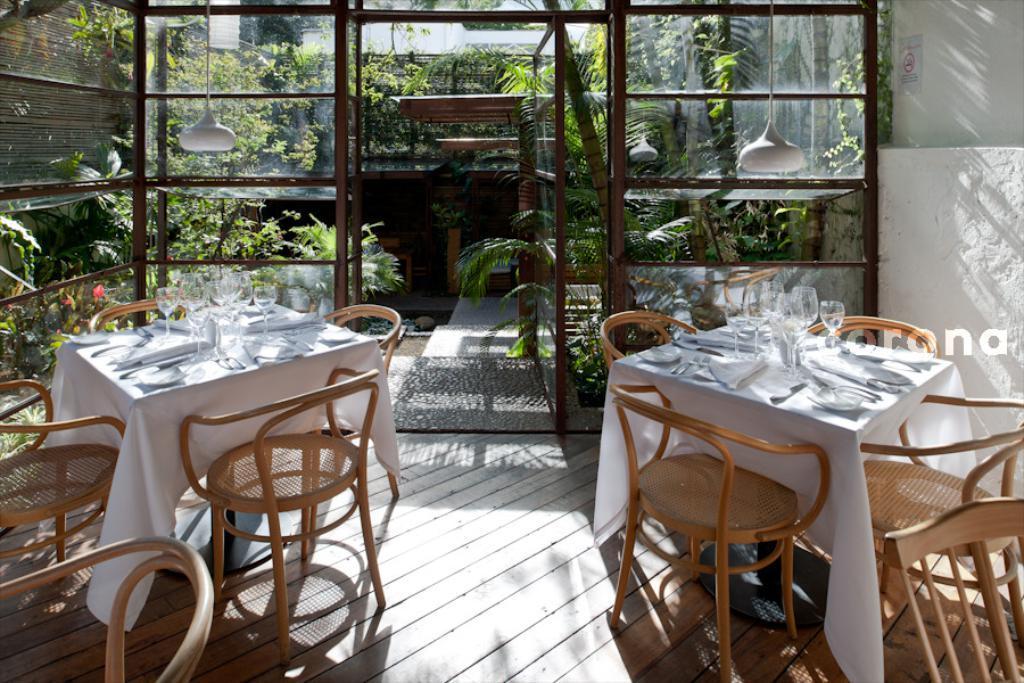Describe this image in one or two sentences. In this image I can see two tables and number of chairs. On these tables I can see number of glasses, white colour table cloths, few white towels, few spoons and few other things. In the background I can see number of plants and on the top side of this image I can see two lights. On the top right side of this image I can see a sign board on the wall. I can also see a watermark on the right side. 